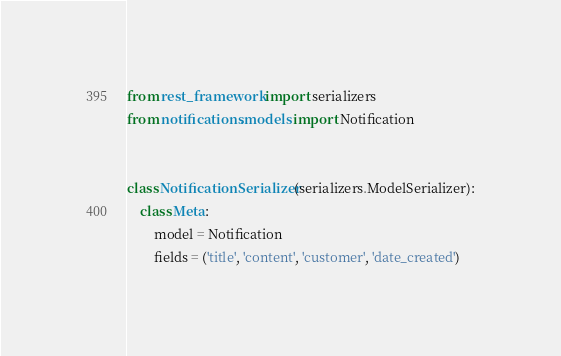Convert code to text. <code><loc_0><loc_0><loc_500><loc_500><_Python_>from rest_framework import serializers
from notifications.models import Notification


class NotificationSerializer(serializers.ModelSerializer):
    class Meta:
        model = Notification
        fields = ('title', 'content', 'customer', 'date_created')
</code> 